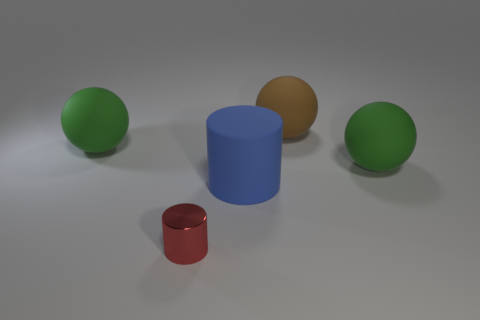Are there any other things that are the same size as the shiny thing? While the shiny red cylinder in the foreground appears unique in size, the green spheres seem to be of a similar diameter. The blue cylinder and the brown sphere, however, are larger than the shiny red cylinder. 